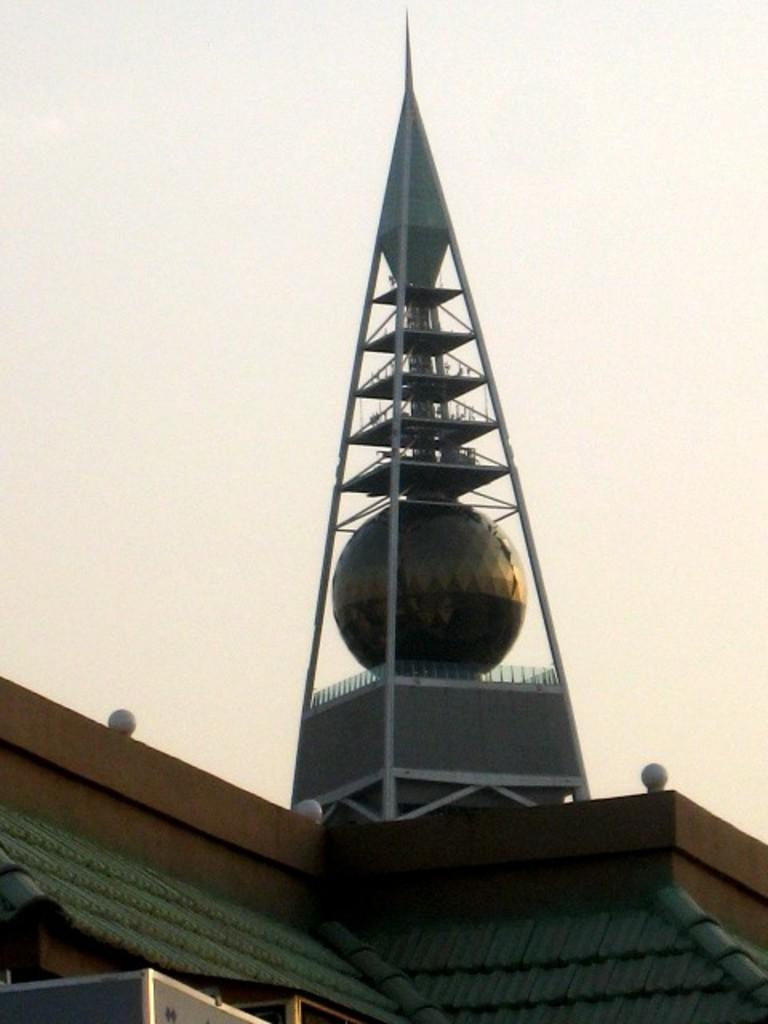What type of location is shown in the image? The image shows a rooftop. What can be seen in the background of the image? There is an architecture visible behind the rooftop. What part of the natural environment is visible in the image? The sky is visible in the image. How many people are jumping on the rooftop in the image? There are no people visible in the image, so it is not possible to determine if anyone is jumping on the rooftop. 